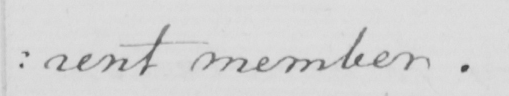Can you read and transcribe this handwriting? : rent member . 